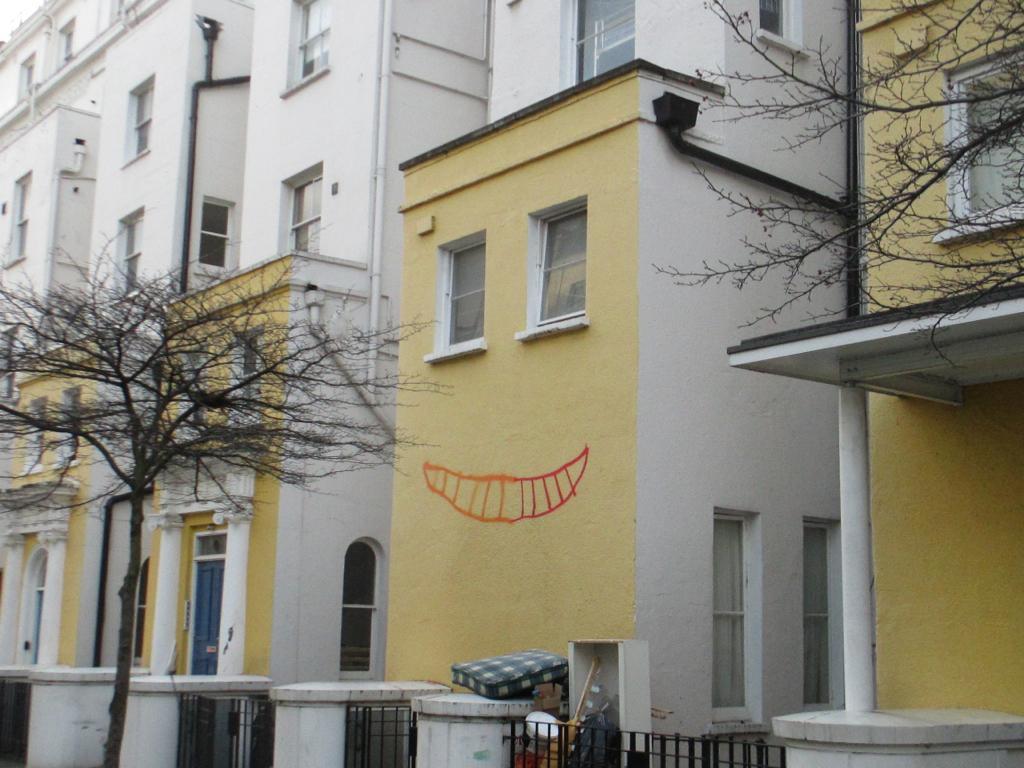Can you describe this image briefly? This picture show few buildings and couple of trees. 